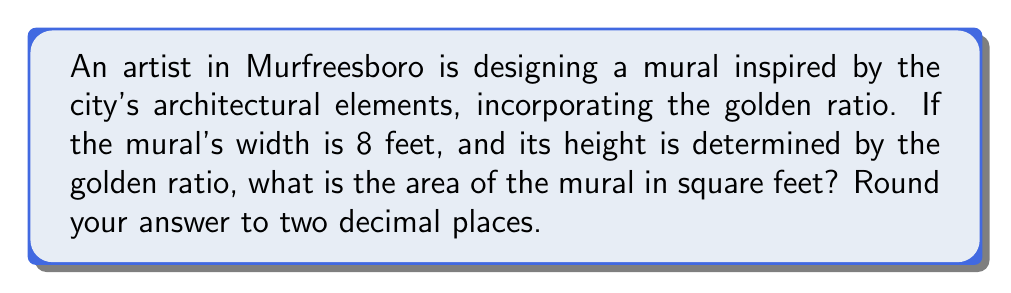Give your solution to this math problem. To solve this problem, we'll follow these steps:

1) The golden ratio, denoted by φ (phi), is approximately equal to 1.618034...

2) In a rectangle with the golden ratio, the ratio of the longer side to the shorter side is φ:1.

3) We're given that the width of the mural is 8 feet. Let's call the height h.

4) The ratio of height to width should be φ:1, so we can set up the equation:

   $$\frac{h}{8} = φ$$

5) Solving for h:

   $$h = 8φ$$

6) Substituting the value of φ:

   $$h = 8 * 1.618034... = 12.94427...$$

7) Now we can calculate the area of the mural:

   $$A = w * h = 8 * 12.94427... = 103.55416...$$

8) Rounding to two decimal places:

   $$A ≈ 103.55 \text{ square feet}$$
Answer: 103.55 sq ft 